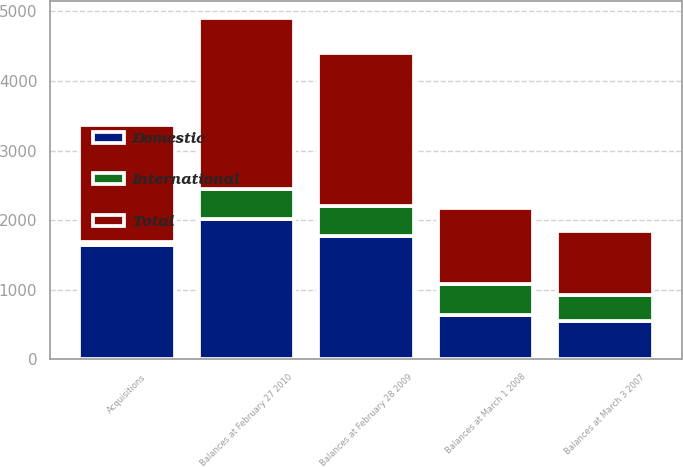Convert chart. <chart><loc_0><loc_0><loc_500><loc_500><stacked_bar_chart><ecel><fcel>Balances at March 3 2007<fcel>Balances at March 1 2008<fcel>Acquisitions<fcel>Balances at February 28 2009<fcel>Balances at February 27 2010<nl><fcel>International<fcel>375<fcel>450<fcel>46<fcel>434<fcel>434<nl><fcel>Domestic<fcel>544<fcel>638<fcel>1641<fcel>1769<fcel>2018<nl><fcel>Total<fcel>919<fcel>1088<fcel>1687<fcel>2203<fcel>2452<nl></chart> 